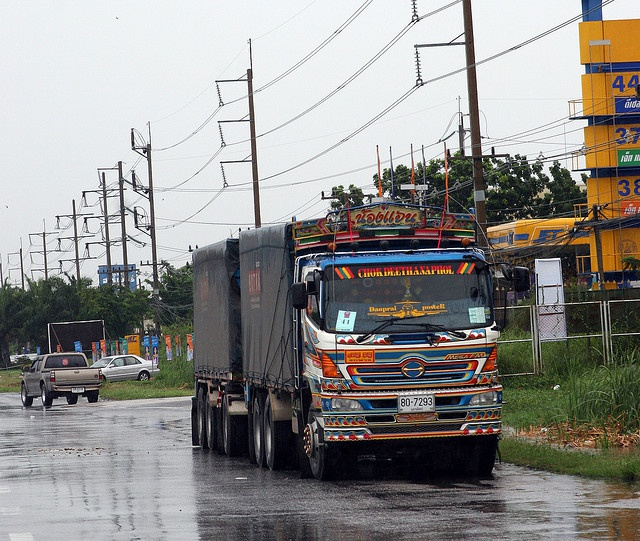Describe the objects in this image and their specific colors. I can see truck in white, black, gray, navy, and darkgray tones, truck in white, gray, black, and darkgray tones, and car in white, darkgray, gray, lightgray, and black tones in this image. 